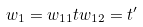Convert formula to latex. <formula><loc_0><loc_0><loc_500><loc_500>w _ { 1 } = w _ { 1 1 } t w _ { 1 2 } = t ^ { \prime }</formula> 